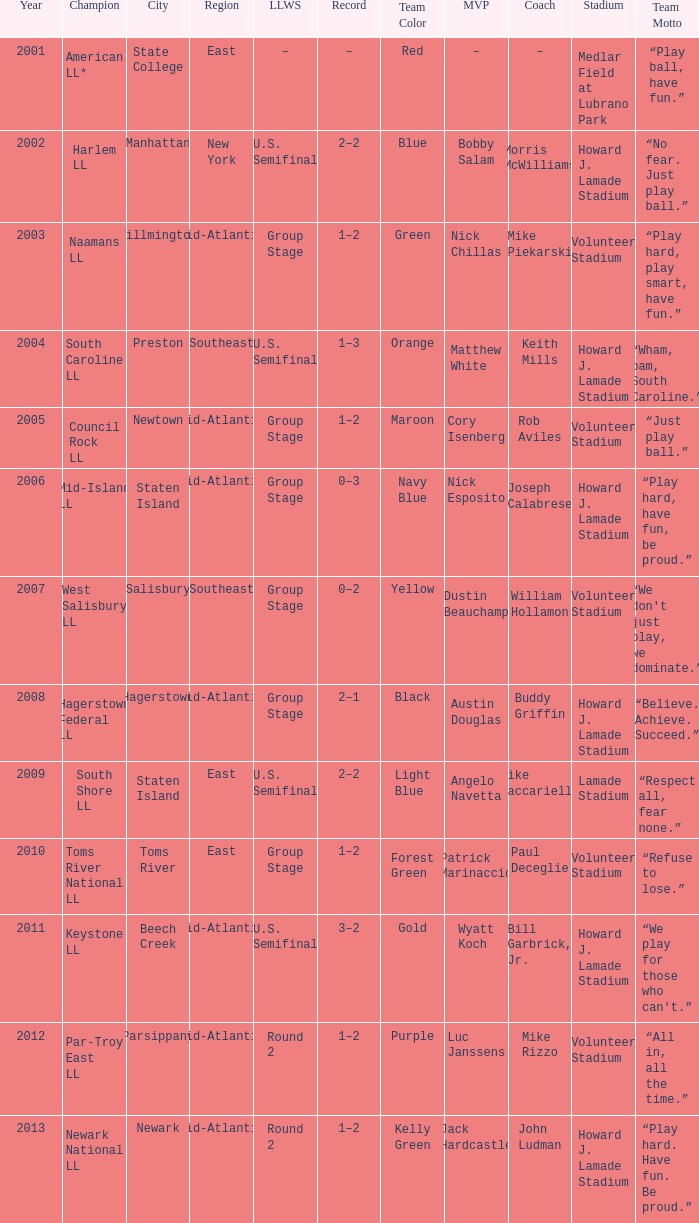Which Little League World Series took place in Parsippany? Round 2. 